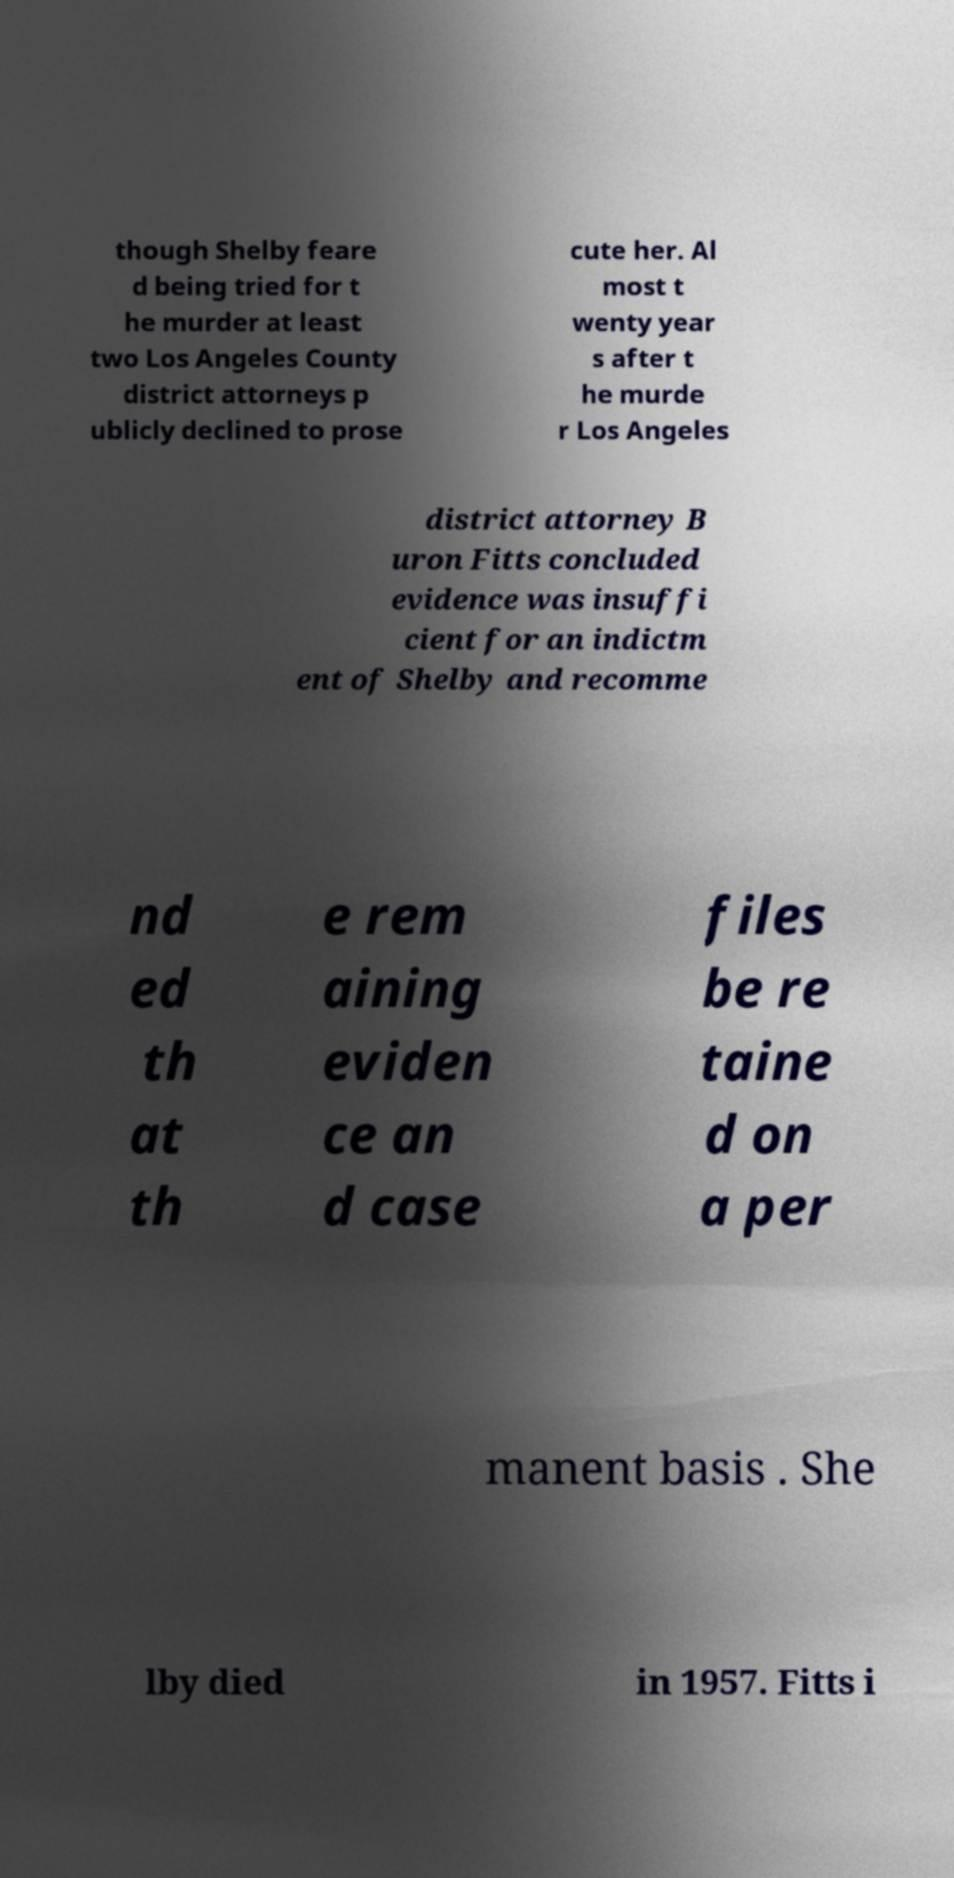Could you assist in decoding the text presented in this image and type it out clearly? though Shelby feare d being tried for t he murder at least two Los Angeles County district attorneys p ublicly declined to prose cute her. Al most t wenty year s after t he murde r Los Angeles district attorney B uron Fitts concluded evidence was insuffi cient for an indictm ent of Shelby and recomme nd ed th at th e rem aining eviden ce an d case files be re taine d on a per manent basis . She lby died in 1957. Fitts i 